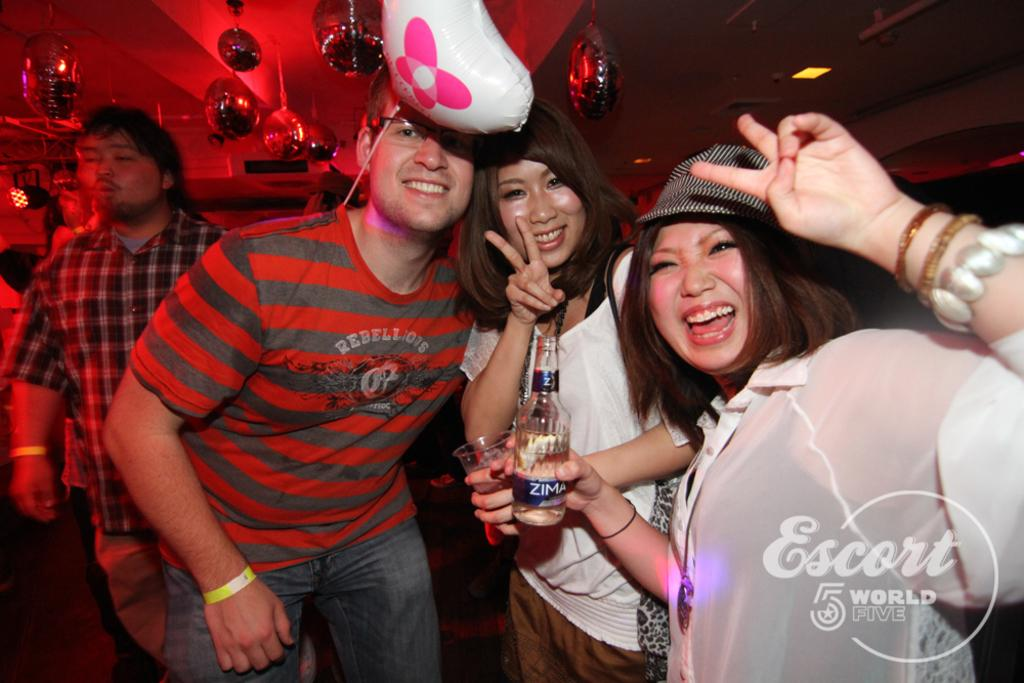How many persons are visible in the image? There are multiple persons in the image. What are two of the persons holding in the image? Two persons are holding a glass and a bottle. What can be seen at the top of the image? There is a balloon and lights at the top of the image. What type of linen is being used as bait in the image? There is no linen or bait present in the image. How much bait is needed to attract the fish in the image? There are no fish or bait present in the image. 